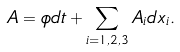<formula> <loc_0><loc_0><loc_500><loc_500>A = \phi d t + \sum _ { i = 1 , 2 , 3 } A _ { i } d x _ { i } .</formula> 